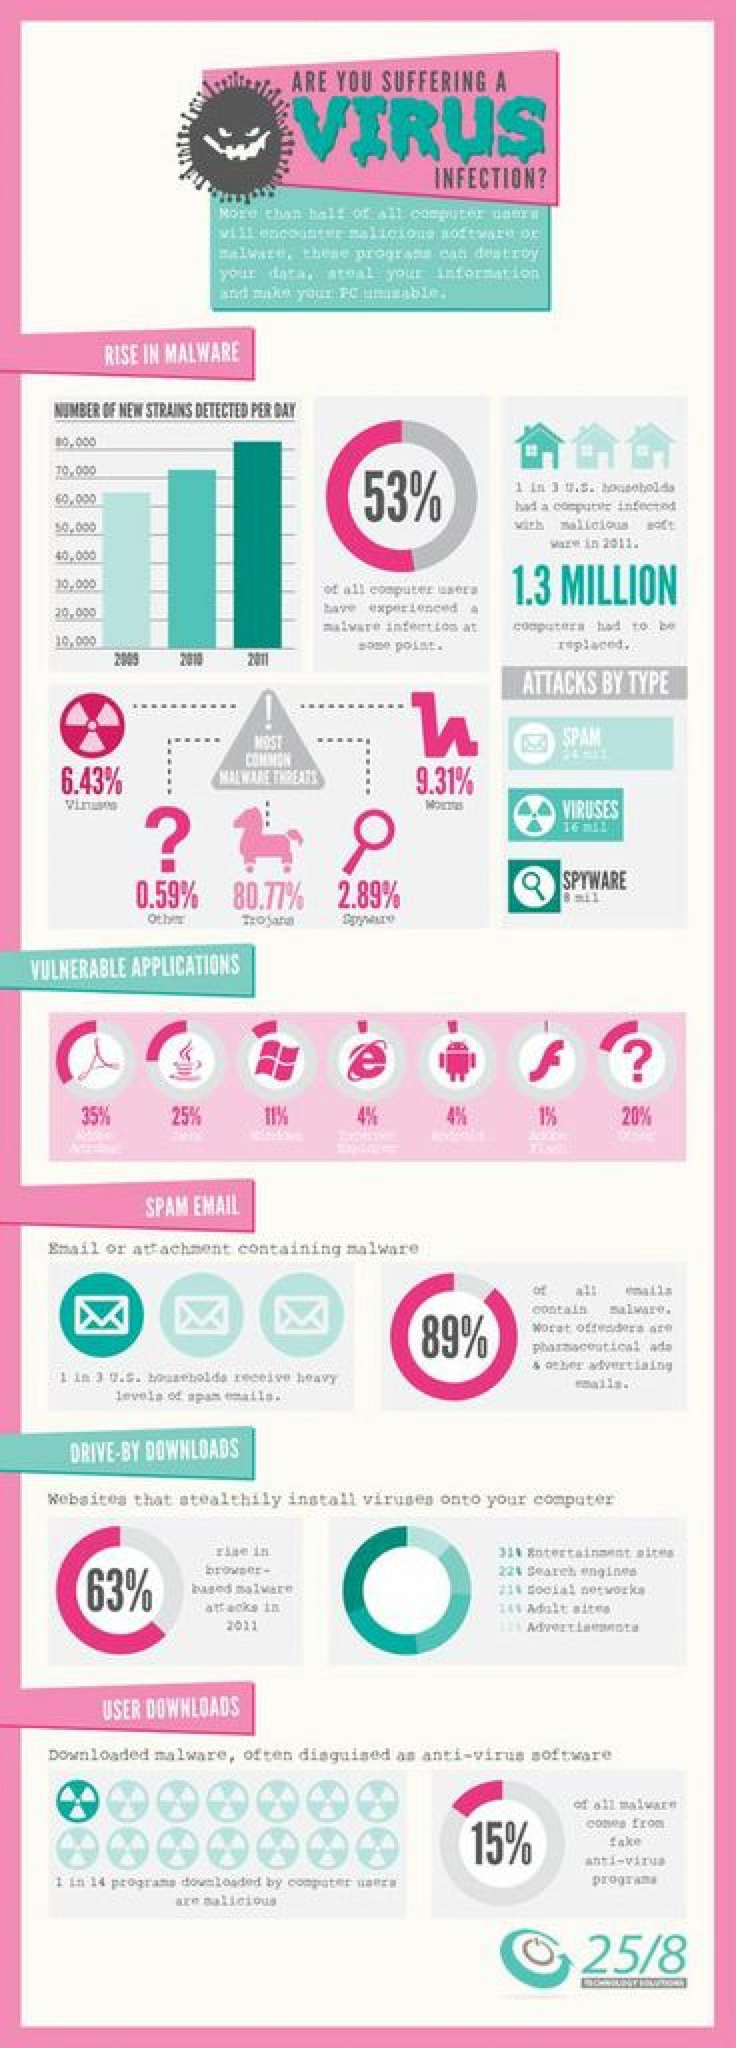What virus is represented by the horse
Answer the question with a short phrase. Trojan What % of computer users have not experienced a malware infection at some point 47 Which years did the new strain detected per day cross 70,000 2010, 2011 